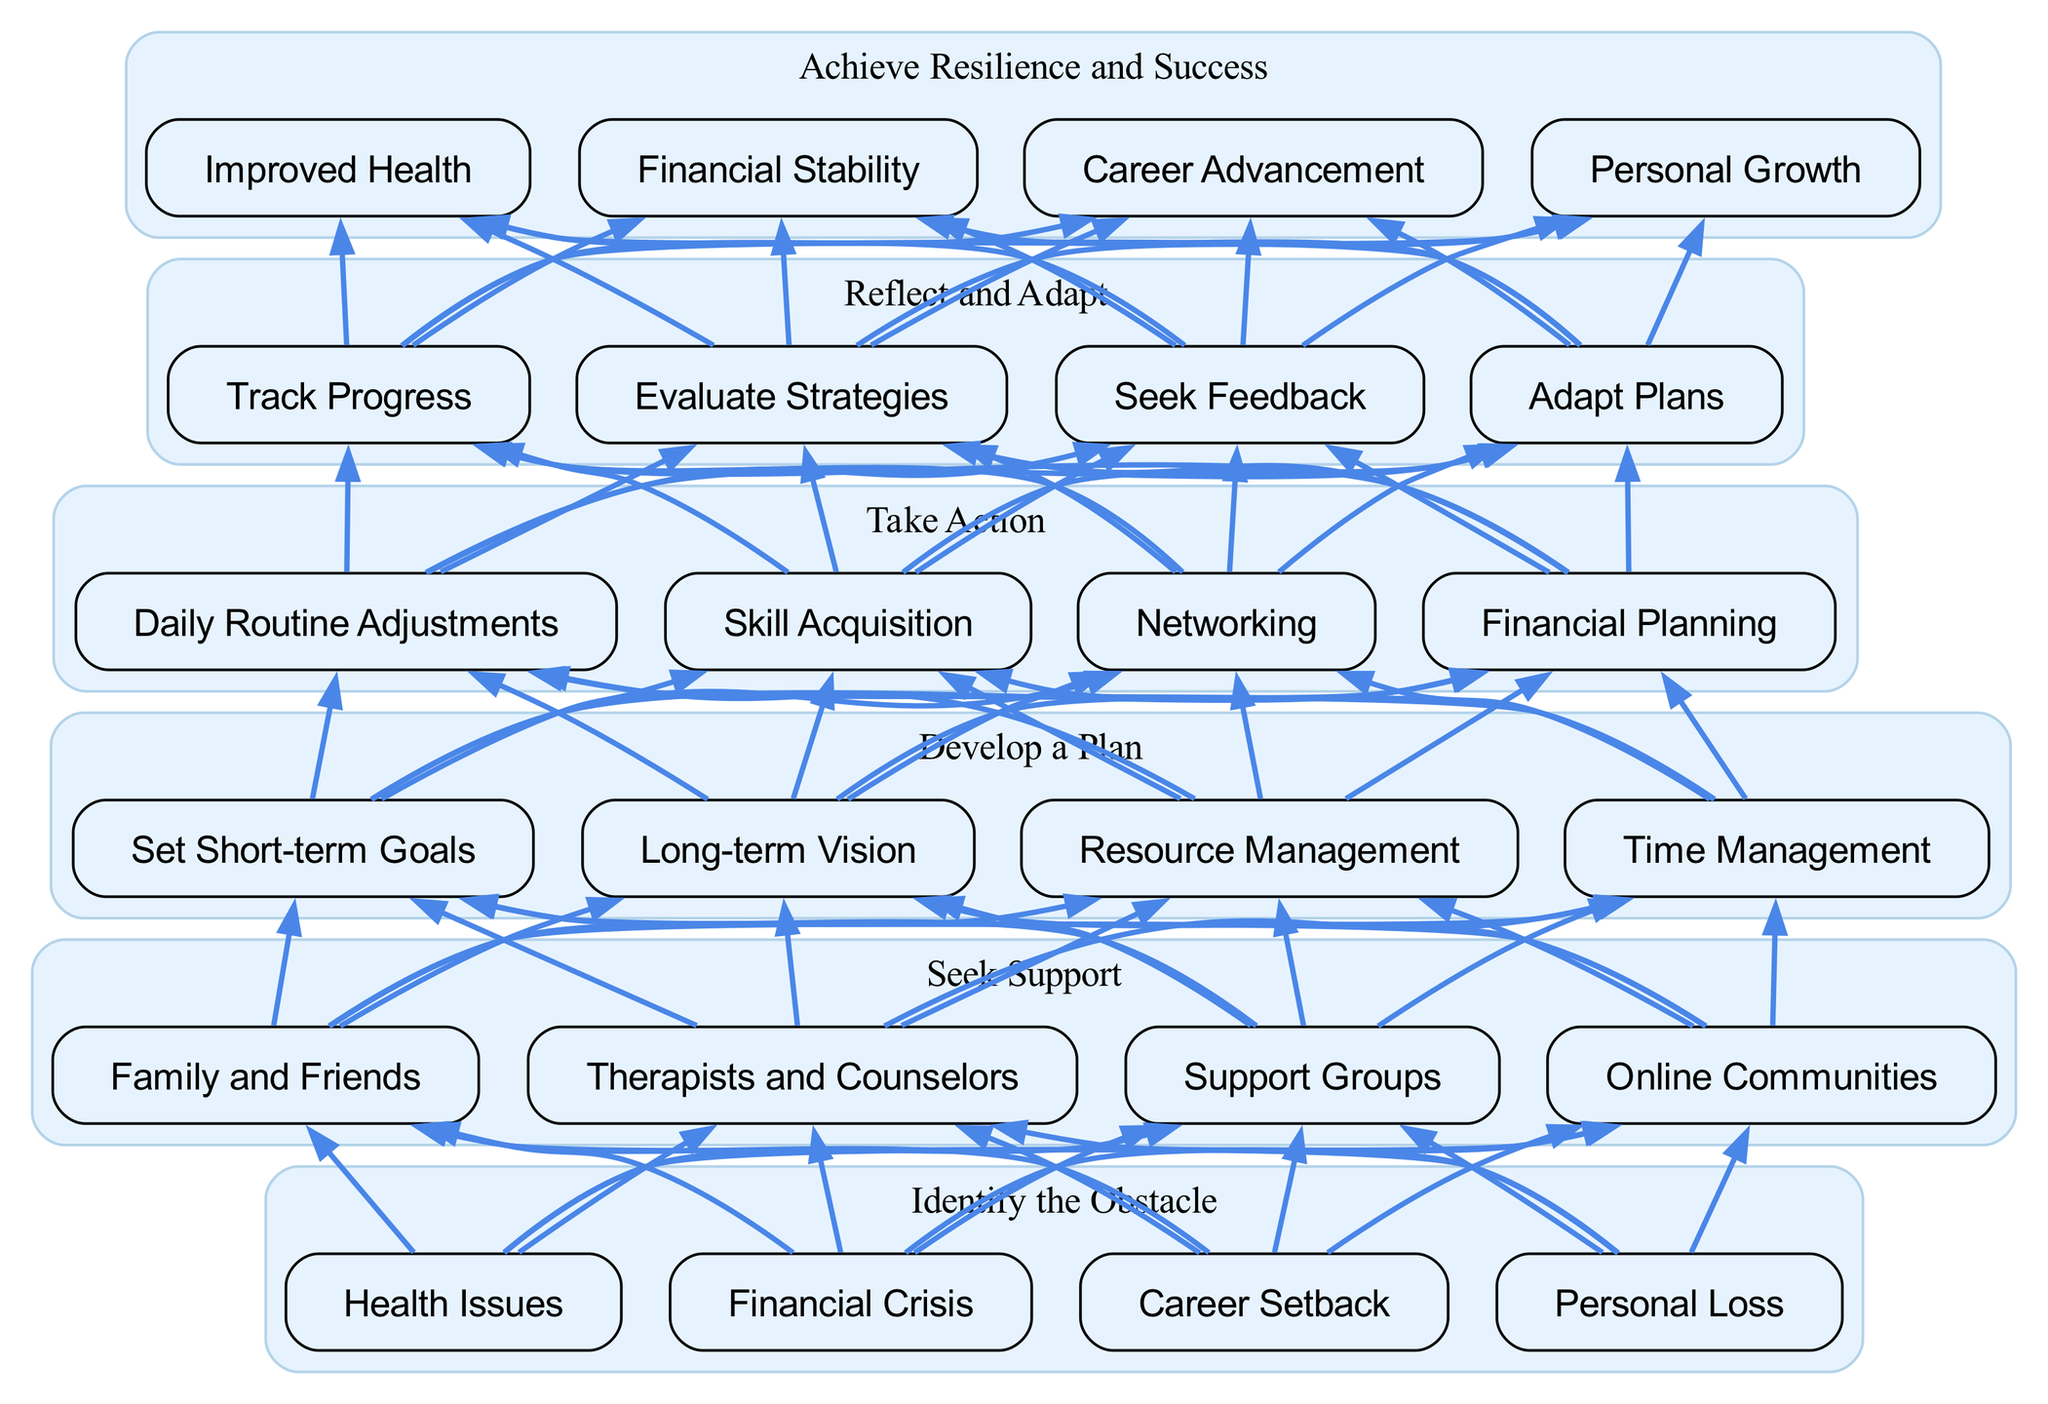What is the first step in overcoming personal obstacles? According to the diagram, the first step at the bottom level is "Identify the Obstacle." This is the starting node that directs the flow upwards.
Answer: Identify the Obstacle How many elements are present in the "Seek Support" level? The "Seek Support" level contains four elements, as indicated in its node description showing "Family and Friends," "Therapists and Counselors," "Support Groups," and "Online Communities."
Answer: Four What are the connections present between the "Reflect and Adapt" and "Take Action" levels? The "Reflect and Adapt" level has four nodes, all of which are connected to the four nodes of the "Take Action" level, establishing a flow from the higher level down to the action level.
Answer: Four connections Which node is aimed at achieving "Personal Growth"? "Personal Growth" is listed as one of the success outcomes in the "Achieve Resilience and Success" level and is specifically one of the last nodes in this top-level group.
Answer: Personal Growth Which elements require a plan to be developed before taking action? The "Develop a Plan" level elements, specifically "Set Short-term Goals," "Long-term Vision," "Resource Management," and "Time Management," must be established before proceeding to take action at the higher level.
Answer: Develop a Plan How many total nodes are in the flow chart? By counting the elements in each level—four in "Identify the Obstacle," four in "Seek Support," four in "Develop a Plan," four in "Take Action," four in "Reflect and Adapt," and four in "Achieve Resilience and Success," the total sums up to twenty-four nodes in total.
Answer: Twenty-four What step follows after developing a plan according to the flow chart? The next step following the "Develop a Plan" level is the "Take Action" level, which encompasses different actions individuals can take to confront their obstacles.
Answer: Take Action What type of connections does the diagram represent from bottom to top? The diagram represents directed connections that guide the process of overcoming obstacles; each level is connected in a flow demonstrating a step-by-step progression towards achieving resilience and success.
Answer: Directed connections 